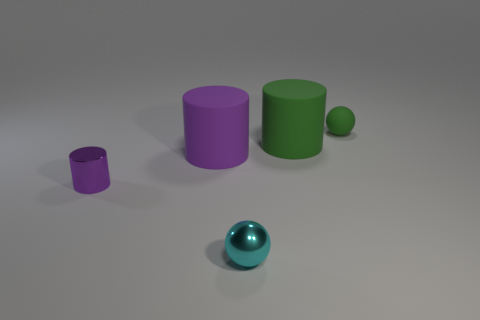Subtract 1 cylinders. How many cylinders are left? 2 Add 4 metallic things. How many objects exist? 9 Subtract all spheres. How many objects are left? 3 Subtract all green things. Subtract all shiny things. How many objects are left? 1 Add 5 purple objects. How many purple objects are left? 7 Add 4 tiny blue objects. How many tiny blue objects exist? 4 Subtract 0 yellow balls. How many objects are left? 5 